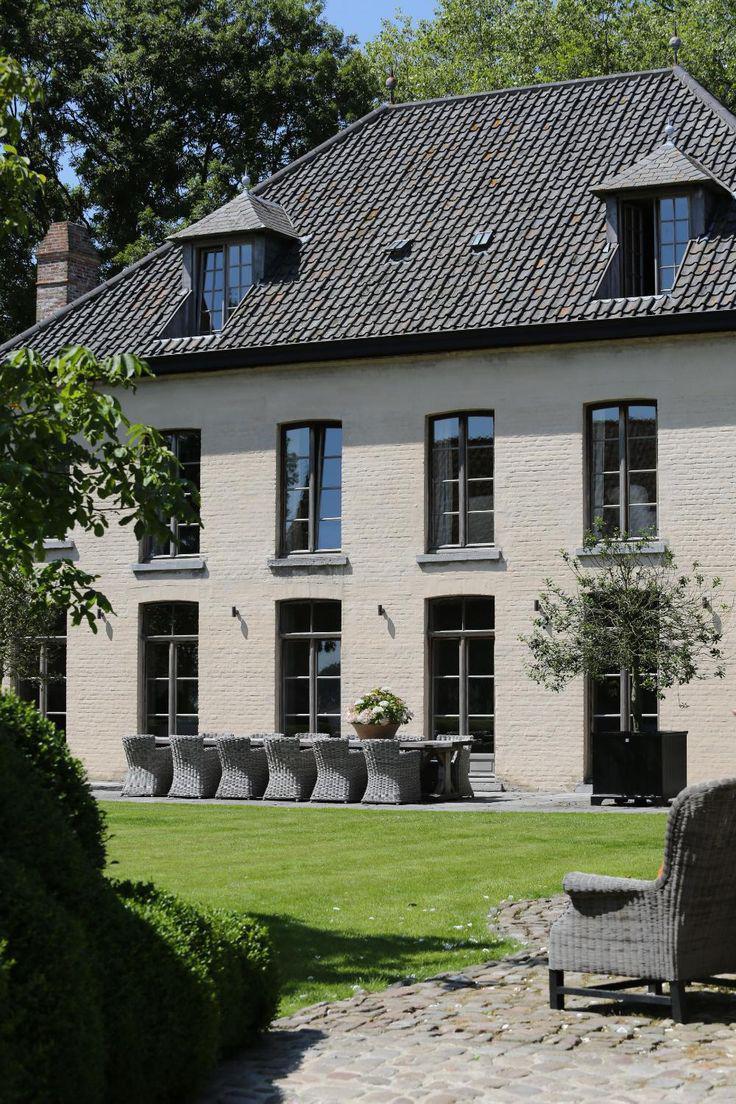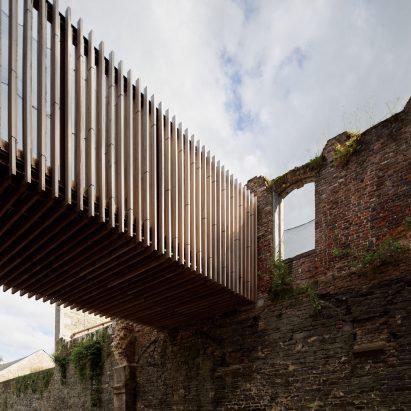The first image is the image on the left, the second image is the image on the right. Assess this claim about the two images: "There is a cozy white house on a level ground with trees behind it.". Correct or not? Answer yes or no. Yes. 